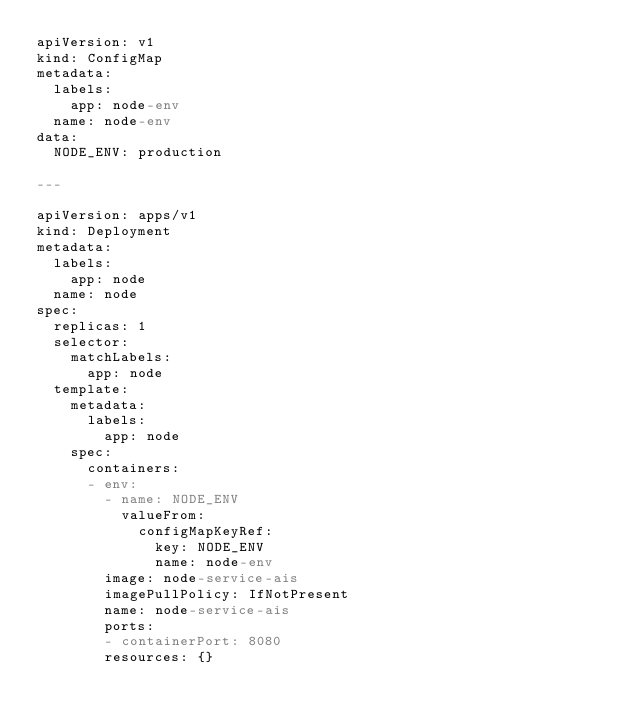Convert code to text. <code><loc_0><loc_0><loc_500><loc_500><_YAML_>apiVersion: v1
kind: ConfigMap
metadata:
  labels:
    app: node-env
  name: node-env
data:
  NODE_ENV: production

---

apiVersion: apps/v1
kind: Deployment
metadata:
  labels:
    app: node
  name: node
spec:
  replicas: 1
  selector:
    matchLabels:
      app: node
  template:
    metadata:
      labels:
        app: node
    spec:
      containers:
      - env:
        - name: NODE_ENV
          valueFrom:
            configMapKeyRef:
              key: NODE_ENV
              name: node-env
        image: node-service-ais
        imagePullPolicy: IfNotPresent
        name: node-service-ais
        ports:
        - containerPort: 8080
        resources: {}
</code> 